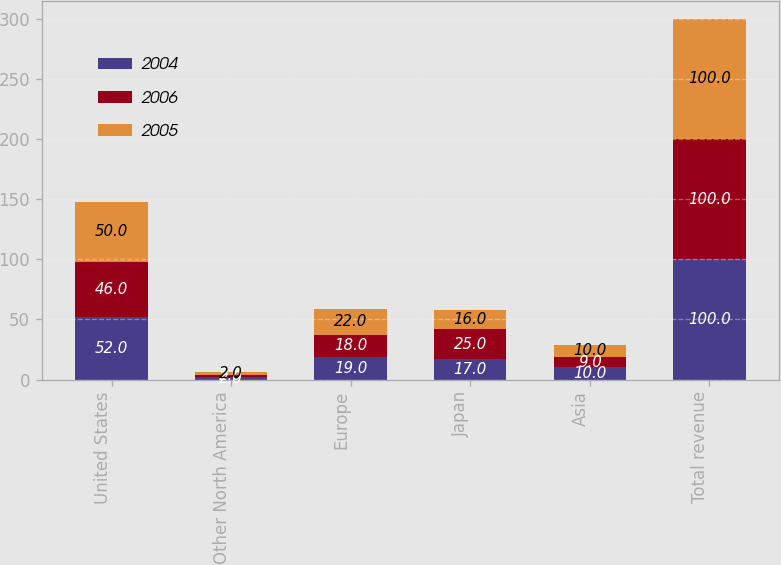Convert chart to OTSL. <chart><loc_0><loc_0><loc_500><loc_500><stacked_bar_chart><ecel><fcel>United States<fcel>Other North America<fcel>Europe<fcel>Japan<fcel>Asia<fcel>Total revenue<nl><fcel>2004<fcel>52<fcel>2<fcel>19<fcel>17<fcel>10<fcel>100<nl><fcel>2006<fcel>46<fcel>2<fcel>18<fcel>25<fcel>9<fcel>100<nl><fcel>2005<fcel>50<fcel>2<fcel>22<fcel>16<fcel>10<fcel>100<nl></chart> 